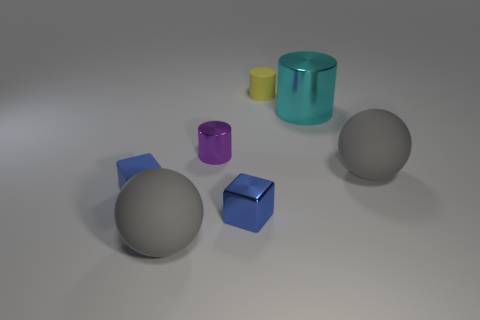Could you describe the lighting condition in the scene? The lighting in this image is soft and diffused, with multiple shadows indicating the presence of more than one light source or a light source with a broad spread. The relative lack of harsh shadows or bright highlights suggests indoor lighting conditions with ambient light. How does the lighting affect the appearance of the objects? The soft lighting helps to reveal the texture and material of the objects by providing gentle gradients of light and shadow. This allows for clearer distinction between the shiny, reflective objects and those with matte or translucent properties. 